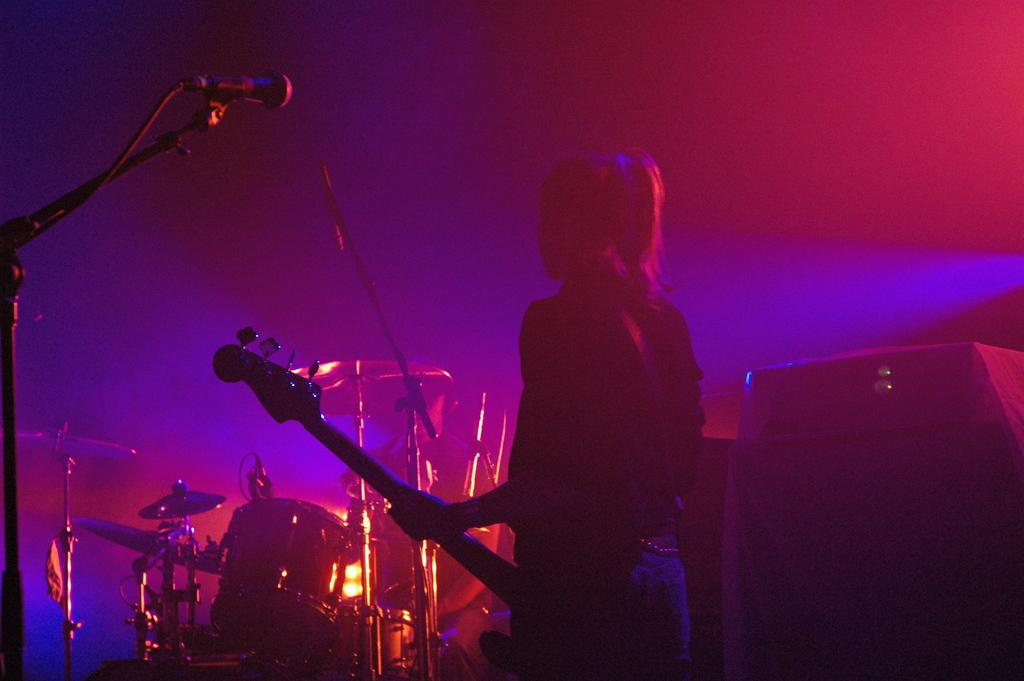What is the main subject of the image? There is a person in the image. What is the person doing in the image? The person is standing and holding a guitar. What other musical instruments are visible in the image? There is a drum set in front of the person. What equipment might be used for amplifying the person's voice in the image? There is a microphone (mic) in front of the person. What is the price of the manager's shame in the image? There is no manager or shame present in the image; it features a person holding a guitar, a drum set, and a microphone. 